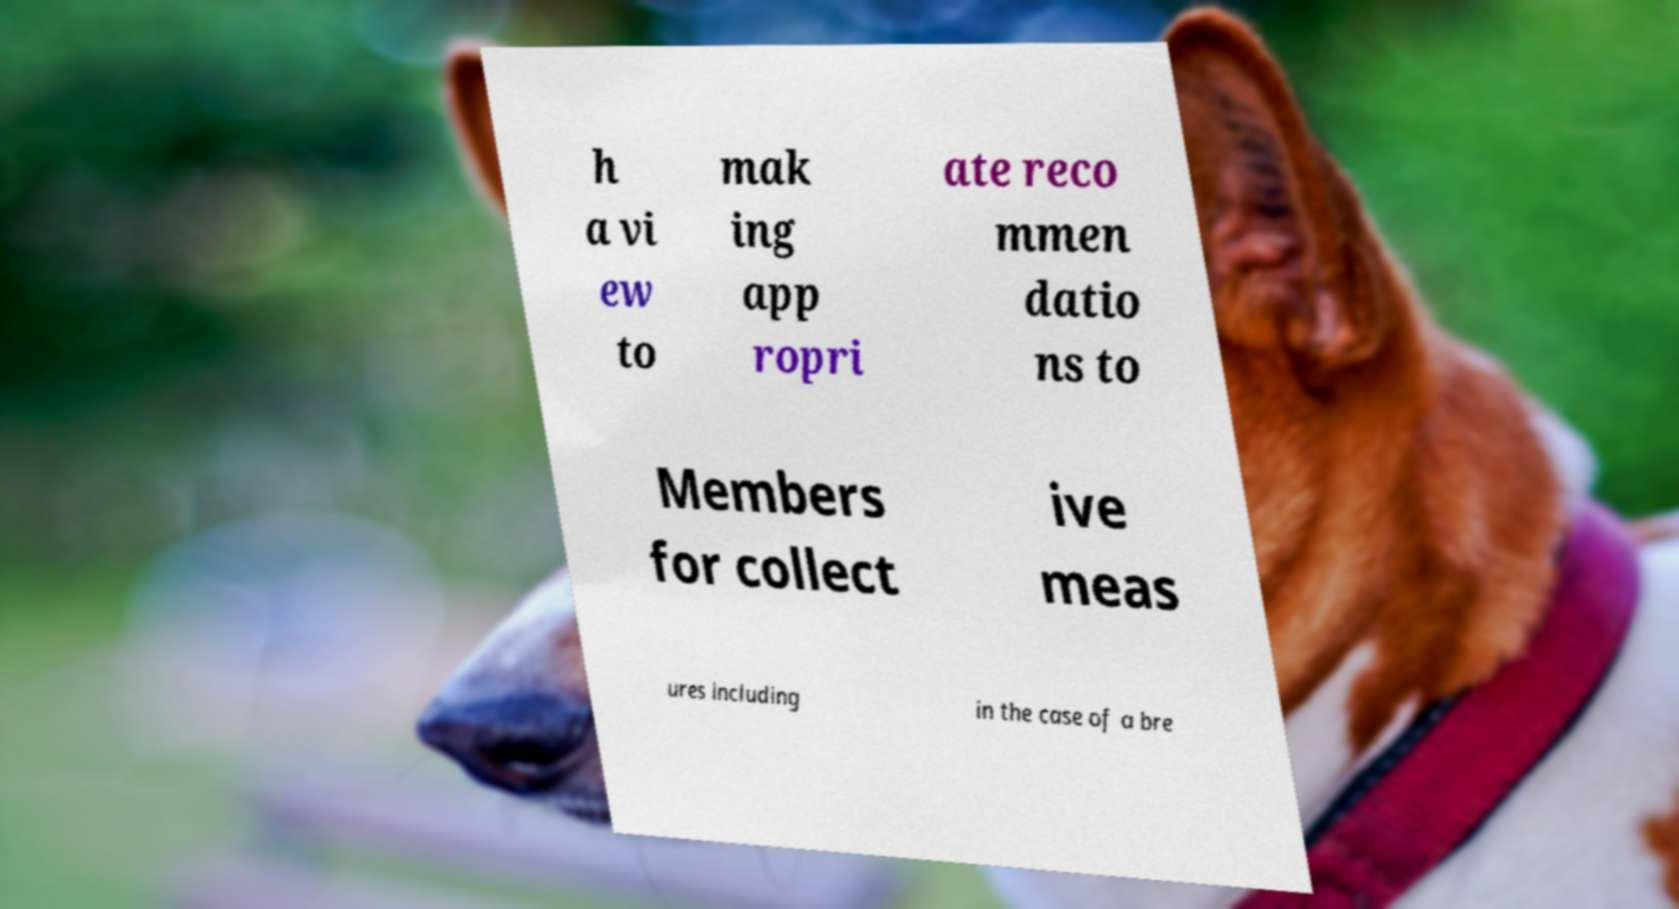Can you read and provide the text displayed in the image?This photo seems to have some interesting text. Can you extract and type it out for me? h a vi ew to mak ing app ropri ate reco mmen datio ns to Members for collect ive meas ures including in the case of a bre 